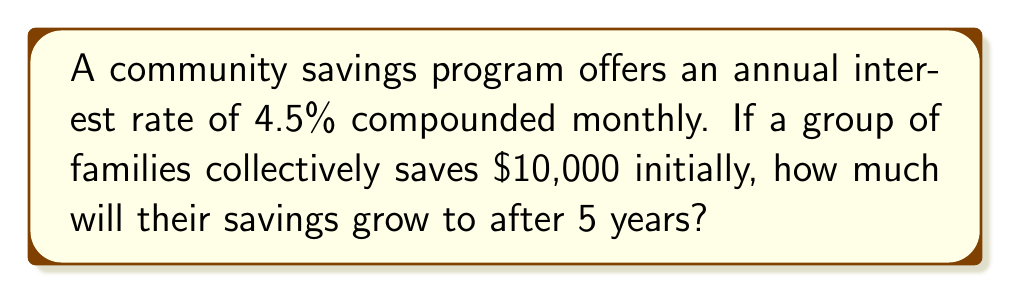What is the answer to this math problem? To solve this problem, we'll use the compound interest formula:

$$A = P(1 + \frac{r}{n})^{nt}$$

Where:
$A$ = final amount
$P$ = principal (initial investment)
$r$ = annual interest rate (in decimal form)
$n$ = number of times interest is compounded per year
$t$ = number of years

Given:
$P = $10,000$
$r = 4.5\% = 0.045$
$n = 12$ (compounded monthly)
$t = 5$ years

Let's substitute these values into the formula:

$$A = 10000(1 + \frac{0.045}{12})^{12 \cdot 5}$$

$$A = 10000(1 + 0.00375)^{60}$$

$$A = 10000(1.00375)^{60}$$

Using a calculator:

$$A = 10000 \cdot 1.2508656$$

$$A = 12508.66$$

Rounding to the nearest cent:

$$A = $12,508.66$$
Answer: $12,508.66 